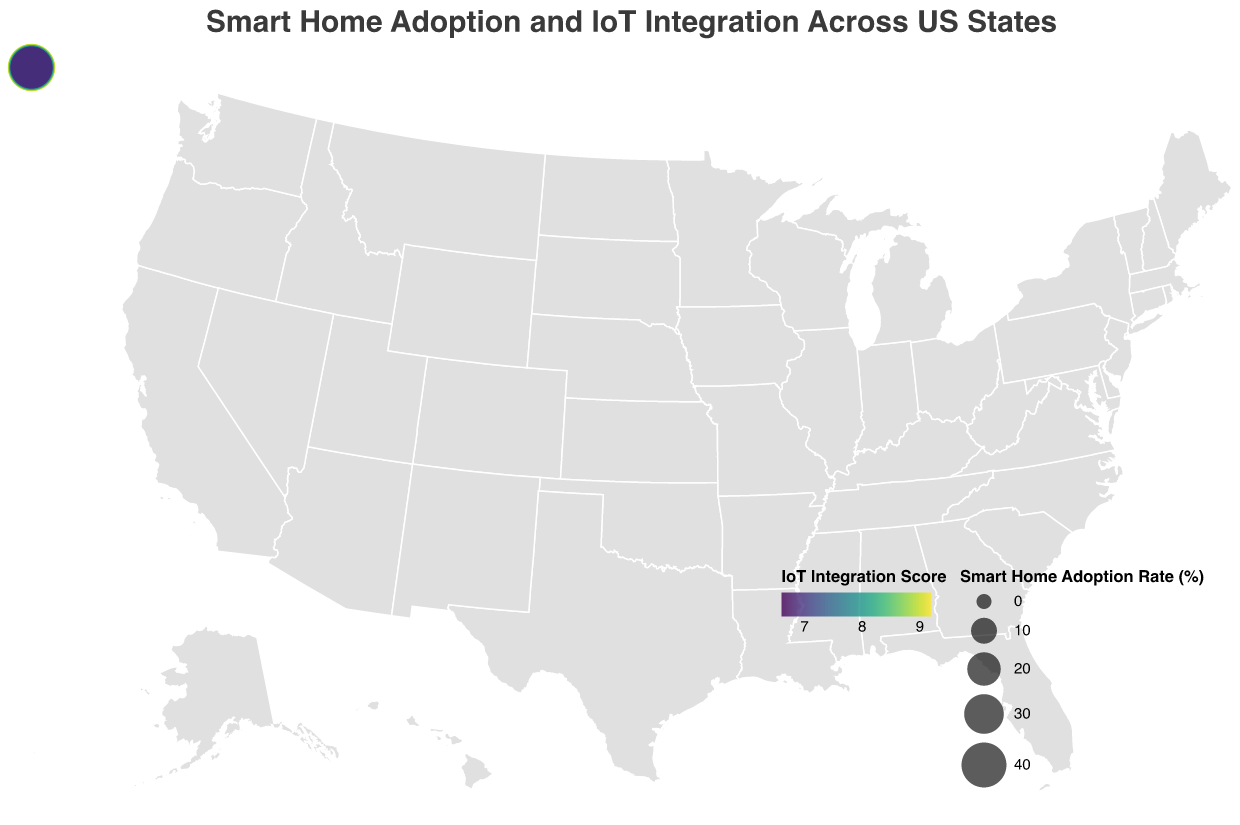Which state has the highest smart home adoption rate? The size of the circles indicates the smart home adoption rate. The circle for Washington is the largest among all states.
Answer: Washington Which state has the lowest smart home adoption rate? The size of the circles indicates the smart home adoption rate. The circle for Ohio is the smallest among all states.
Answer: Ohio How does California compare to Texas in terms of IoT Device Integration Score? The color intensity indicates the IoT Device Integration Score. California has a darker shade compared to Texas, meaning California has a higher IoT Device Integration Score.
Answer: California has a higher score What is the relationship between smart home adoption rates and IoT Device Integration Scores in Washington and Oregon? Both states have top rankings for smart home adoption rates and high IoT Device Integration Scores, which are represented by larger and darker circles for both states.
Answer: High adoption rates and integration scores for both states Which state in the Southeast has the highest smart home adoption rate and how does it compare to that of an average state? Among states in the Southeast, Florida has the highest smart home adoption rate at 36.8%. To find the average rate: (Sum of all rates) / 20 = (42.5 + 38.2 + 36.8 + ... + 34.2) / 20 = 37.93. Florida has a slightly below-average adoption rate.
Answer: Florida, slightly below average How are the Midwest states Illinois and Ohio different in terms of their IoT Device Integration Scores? The color intensity indicates the IoT Device Integration Score. Illinois has a darker shade compared to Ohio, indicating Illinois has a higher IoT Device Integration Score.
Answer: Illinois has a higher score What can be observed about the states with smart home adoption rates above 40%? States with smart home adoption rates above 40% include California, Washington, Colorado, Massachusetts, Oregon, and Utah. These states also have high IoT Device Integration Scores reflected by darker colors.
Answer: High adoption rates and integration scores What is the average smart home adoption rate for states that have an IoT Device Integration Score of 8 and higher? Compute the average smart home adoption rate for states with scores 8 and above. Relevant states: CA, WA, CO, AZ, MA, OR, UT, NV, MN. Sum of adoption rates: 42.5 + 45.1 + 43.7 + 39.5 + 41.8 + 44.3 + 42.9 + 40.6 + 38.9 = 379.3. Average = 379.3 / 9 = 42.14.
Answer: 42.14 Is there a general trend between smart home adoption rates and IoT Device Integration Scores among all states? States with higher smart home adoption rates often have corresponding higher IoT Device Integration Scores. Larger circles generally tend to have darker shades.
Answer: Positive correlation 